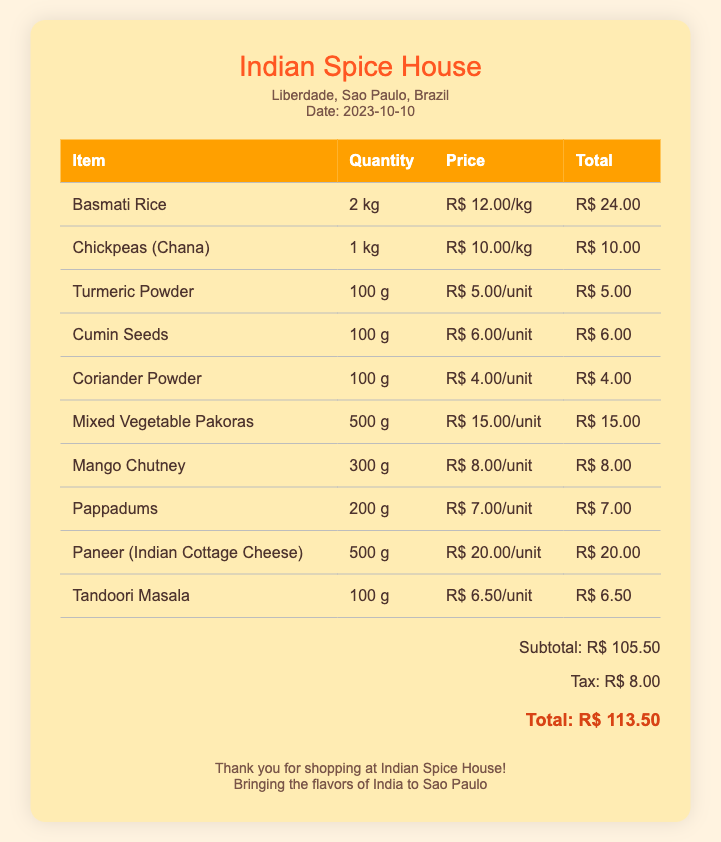What is the name of the store? The store is called Indian Spice House, which is mentioned at the top of the bill.
Answer: Indian Spice House Where is the store located? The store's location, which is listed in the document, is Liberdade, Sao Paulo, Brazil.
Answer: Liberdade, Sao Paulo, Brazil What is the date of the bill? The date on the bill is specified in the document, showing when the purchase was made.
Answer: 2023-10-10 What is the total amount due? The total amount, which includes subtotal and tax, is presented clearly in the document.
Answer: R$ 113.50 How many kilograms of Basmati Rice were purchased? The bill states that 2 kilograms of Basmati Rice were bought, as listed under the item.
Answer: 2 kg Which item has the highest price per unit? Comparing the prices per unit in the bill shows that Paneer is the most expensive item listed.
Answer: Paneer (Indian Cottage Cheese) What is the subtotal before tax? The subtotal is explicitly calculated and presented in the document prior to adding tax.
Answer: R$ 105.50 How much did the Mango Chutney cost? The document lists the price of Mango Chutney next to its quantity.
Answer: R$ 8.00 What type of masala is included in the bill? The bill includes Tandoori Masala, which is listed among the items purchased.
Answer: Tandoori Masala 